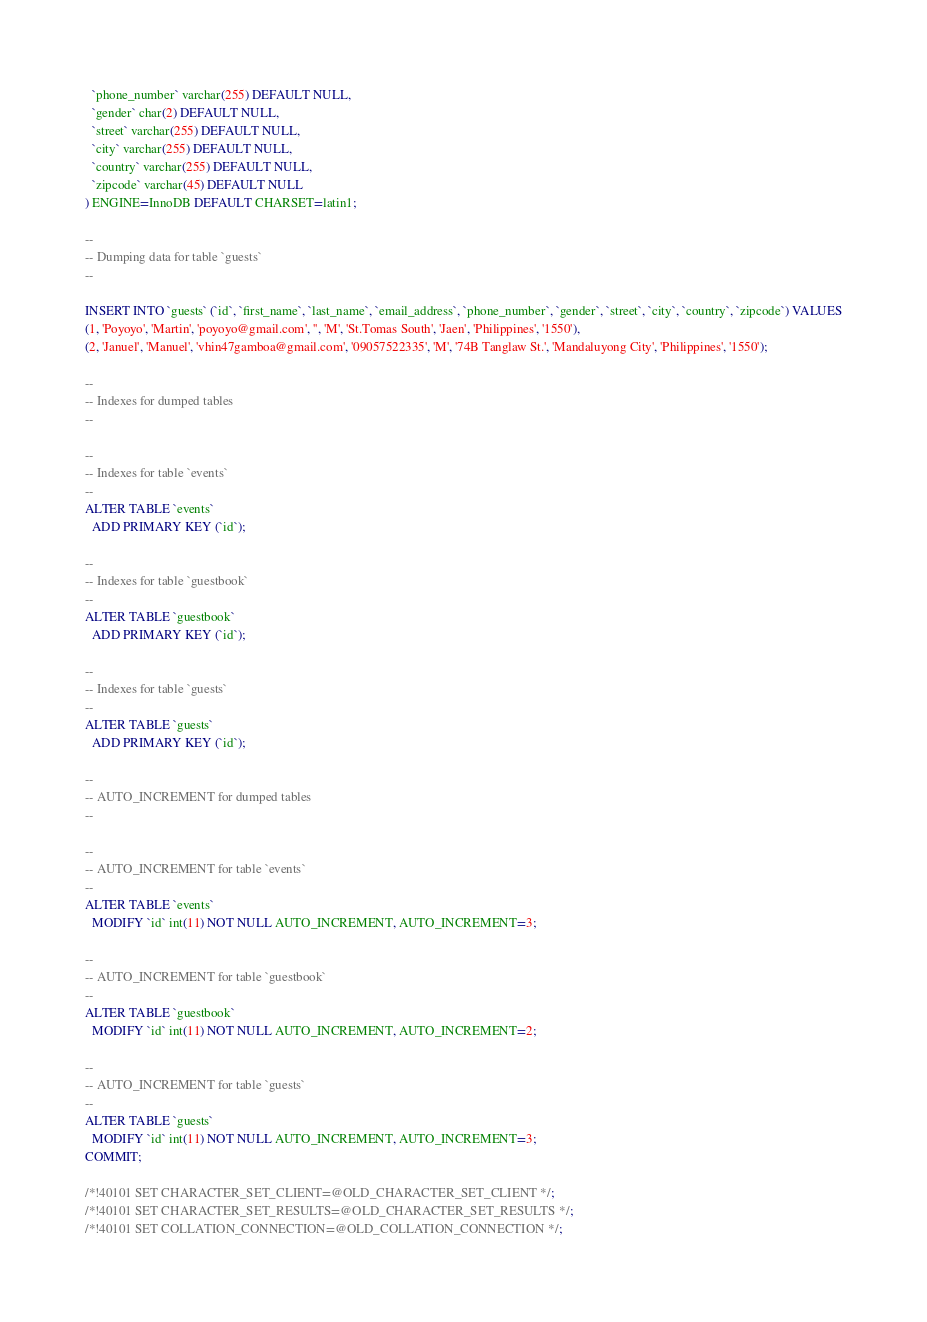<code> <loc_0><loc_0><loc_500><loc_500><_SQL_>  `phone_number` varchar(255) DEFAULT NULL,
  `gender` char(2) DEFAULT NULL,
  `street` varchar(255) DEFAULT NULL,
  `city` varchar(255) DEFAULT NULL,
  `country` varchar(255) DEFAULT NULL,
  `zipcode` varchar(45) DEFAULT NULL
) ENGINE=InnoDB DEFAULT CHARSET=latin1;

--
-- Dumping data for table `guests`
--

INSERT INTO `guests` (`id`, `first_name`, `last_name`, `email_address`, `phone_number`, `gender`, `street`, `city`, `country`, `zipcode`) VALUES
(1, 'Poyoyo', 'Martin', 'poyoyo@gmail.com', '', 'M', 'St.Tomas South', 'Jaen', 'Philippines', '1550'),
(2, 'Januel', 'Manuel', 'vhin47gamboa@gmail.com', '09057522335', 'M', '74B Tanglaw St.', 'Mandaluyong City', 'Philippines', '1550');

--
-- Indexes for dumped tables
--

--
-- Indexes for table `events`
--
ALTER TABLE `events`
  ADD PRIMARY KEY (`id`);

--
-- Indexes for table `guestbook`
--
ALTER TABLE `guestbook`
  ADD PRIMARY KEY (`id`);

--
-- Indexes for table `guests`
--
ALTER TABLE `guests`
  ADD PRIMARY KEY (`id`);

--
-- AUTO_INCREMENT for dumped tables
--

--
-- AUTO_INCREMENT for table `events`
--
ALTER TABLE `events`
  MODIFY `id` int(11) NOT NULL AUTO_INCREMENT, AUTO_INCREMENT=3;

--
-- AUTO_INCREMENT for table `guestbook`
--
ALTER TABLE `guestbook`
  MODIFY `id` int(11) NOT NULL AUTO_INCREMENT, AUTO_INCREMENT=2;

--
-- AUTO_INCREMENT for table `guests`
--
ALTER TABLE `guests`
  MODIFY `id` int(11) NOT NULL AUTO_INCREMENT, AUTO_INCREMENT=3;
COMMIT;

/*!40101 SET CHARACTER_SET_CLIENT=@OLD_CHARACTER_SET_CLIENT */;
/*!40101 SET CHARACTER_SET_RESULTS=@OLD_CHARACTER_SET_RESULTS */;
/*!40101 SET COLLATION_CONNECTION=@OLD_COLLATION_CONNECTION */;
</code> 